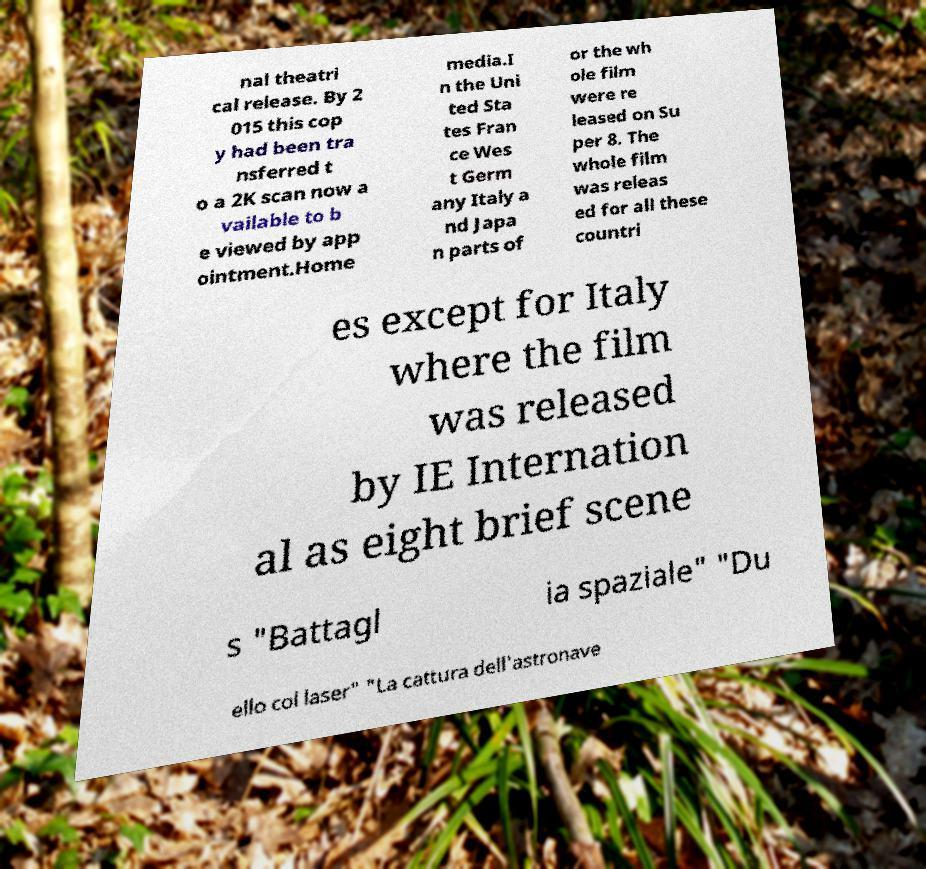I need the written content from this picture converted into text. Can you do that? nal theatri cal release. By 2 015 this cop y had been tra nsferred t o a 2K scan now a vailable to b e viewed by app ointment.Home media.I n the Uni ted Sta tes Fran ce Wes t Germ any Italy a nd Japa n parts of or the wh ole film were re leased on Su per 8. The whole film was releas ed for all these countri es except for Italy where the film was released by IE Internation al as eight brief scene s "Battagl ia spaziale" "Du ello col laser" "La cattura dell'astronave 